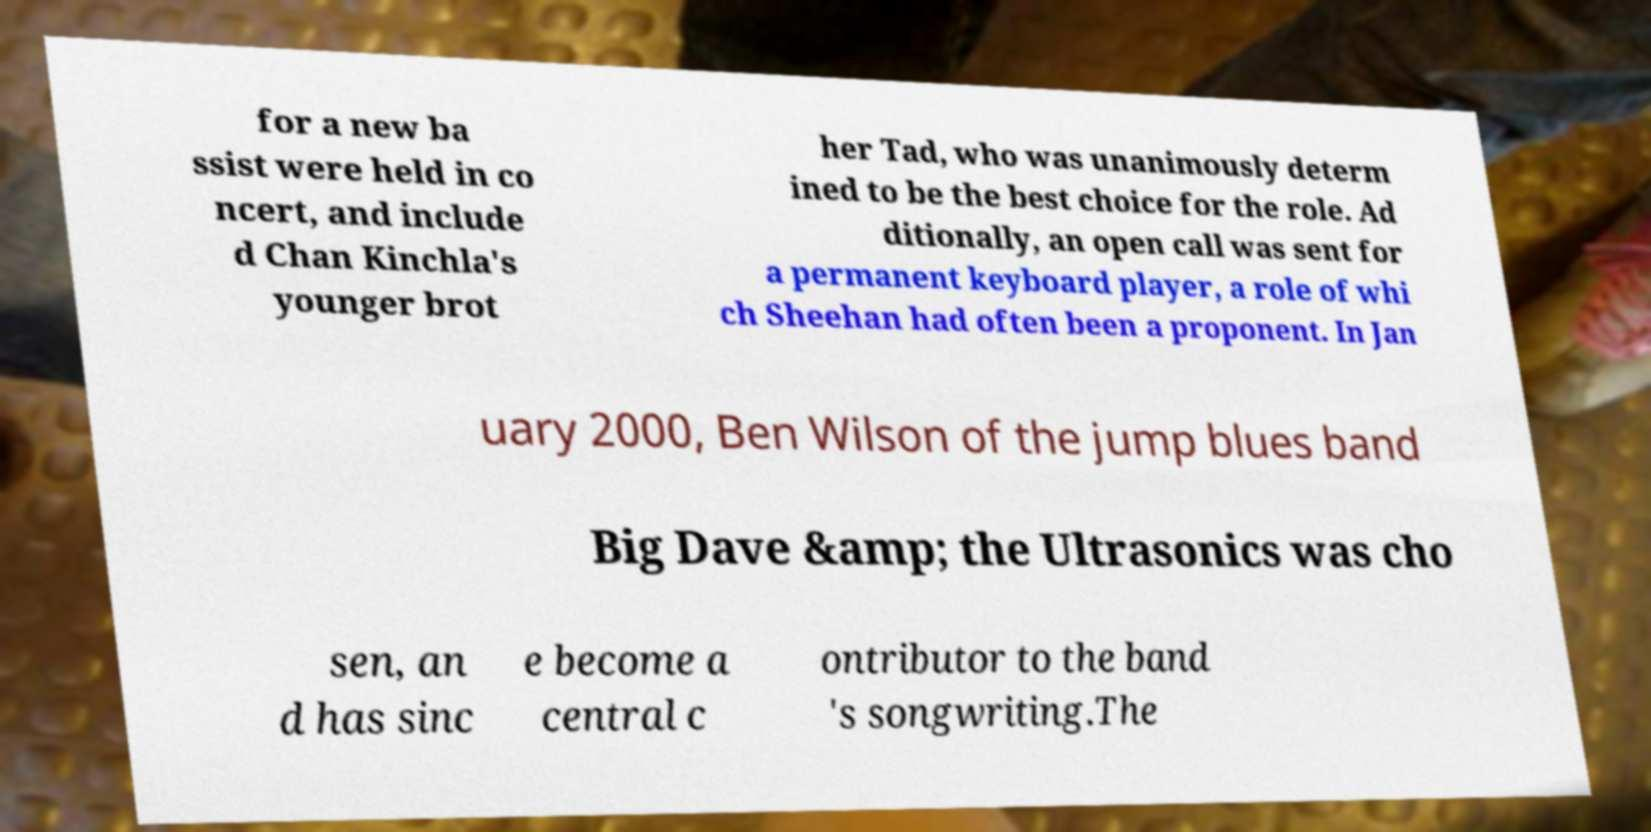Could you extract and type out the text from this image? for a new ba ssist were held in co ncert, and include d Chan Kinchla's younger brot her Tad, who was unanimously determ ined to be the best choice for the role. Ad ditionally, an open call was sent for a permanent keyboard player, a role of whi ch Sheehan had often been a proponent. In Jan uary 2000, Ben Wilson of the jump blues band Big Dave &amp; the Ultrasonics was cho sen, an d has sinc e become a central c ontributor to the band 's songwriting.The 